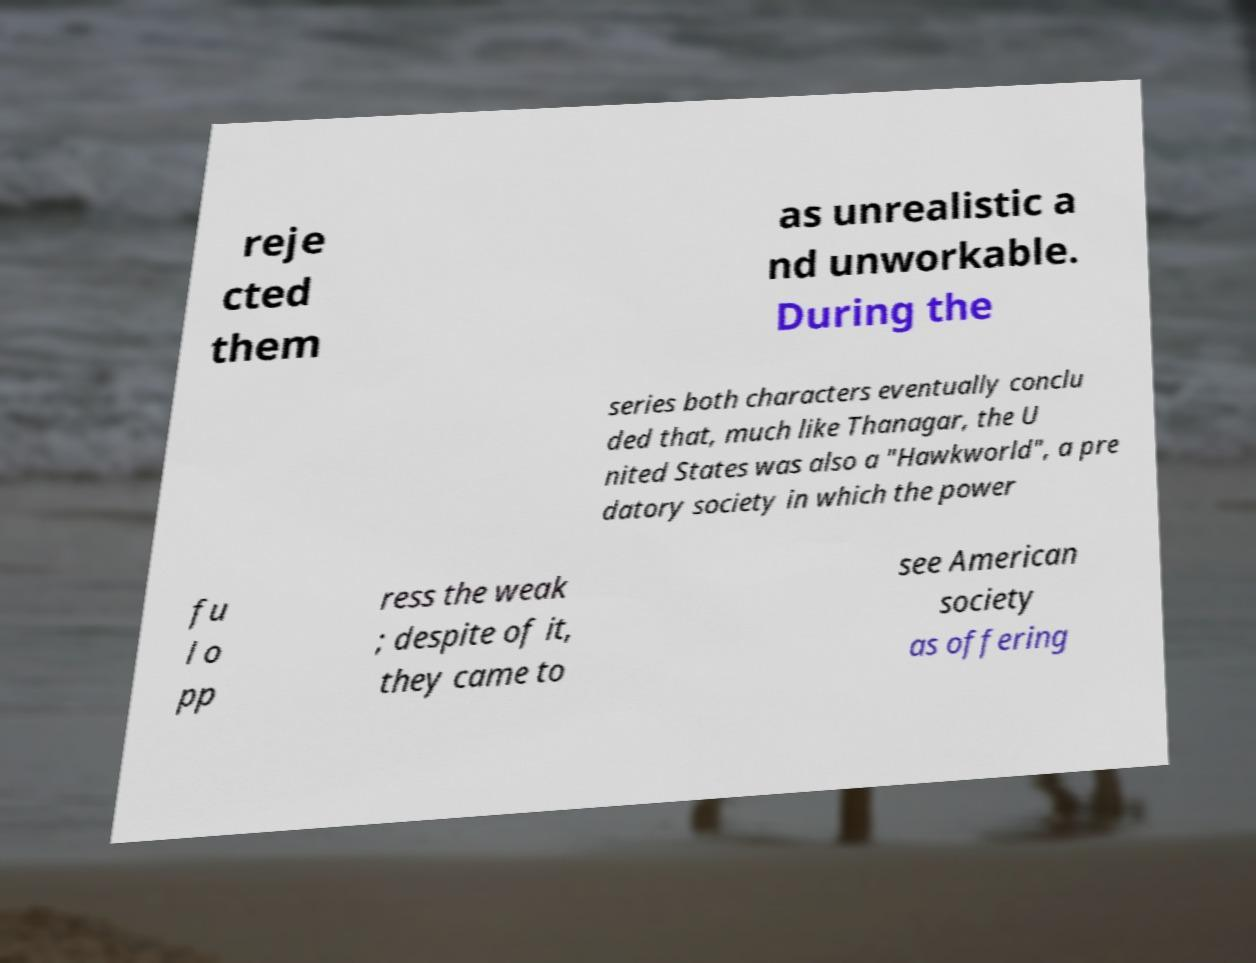Can you read and provide the text displayed in the image?This photo seems to have some interesting text. Can you extract and type it out for me? reje cted them as unrealistic a nd unworkable. During the series both characters eventually conclu ded that, much like Thanagar, the U nited States was also a "Hawkworld", a pre datory society in which the power fu l o pp ress the weak ; despite of it, they came to see American society as offering 